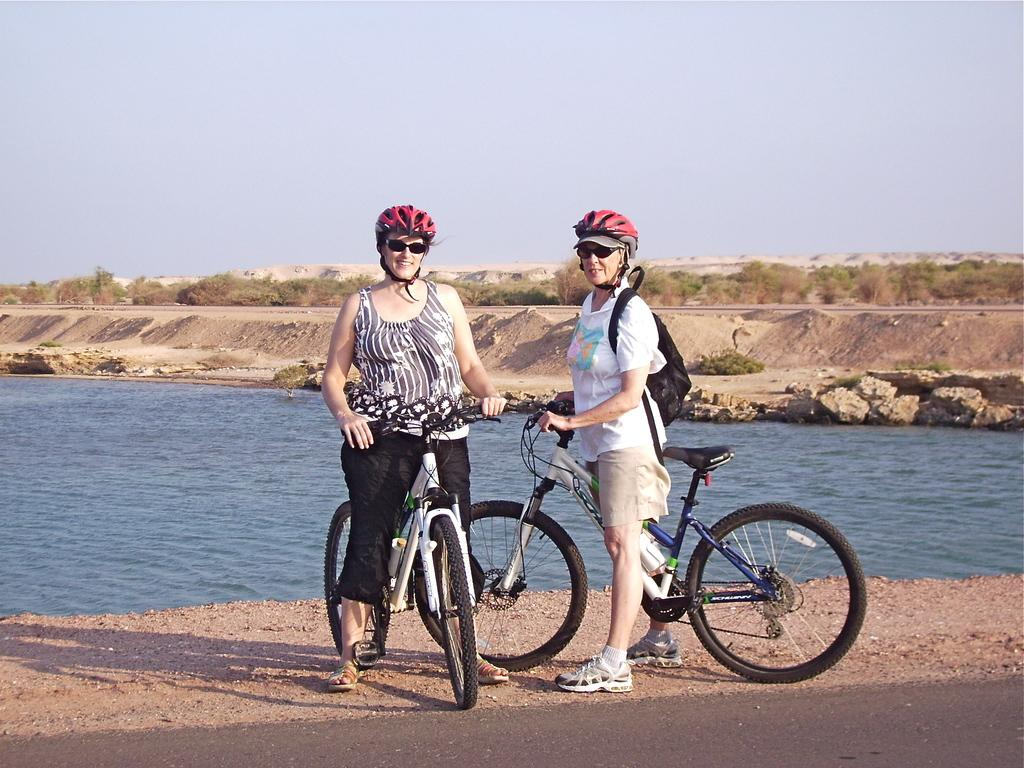How many people are in the image? There are two people in the image. What are the people doing in the image? The people are standing with their bicycles. Where are the bicycles located in the image? The bicycles are on a path. What can be seen in the background of the image? Water, sand, trees, and the sky are visible in the background. What type of hose is being used by the people in the image? There is no hose present in the image. What is the rate at which the people are riding their bicycles in the image? The image is a still photograph, so it does not show the people riding their bicycles or provide information about their speed. 